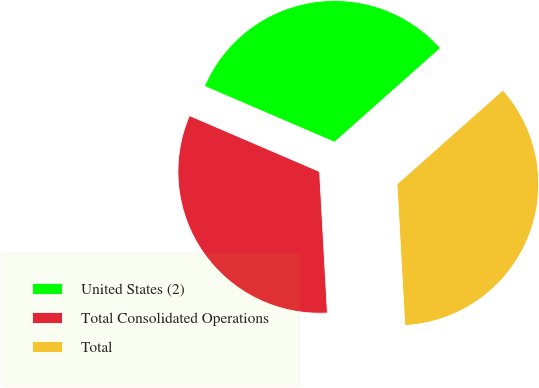<chart> <loc_0><loc_0><loc_500><loc_500><pie_chart><fcel>United States (2)<fcel>Total Consolidated Operations<fcel>Total<nl><fcel>31.98%<fcel>32.34%<fcel>35.68%<nl></chart> 